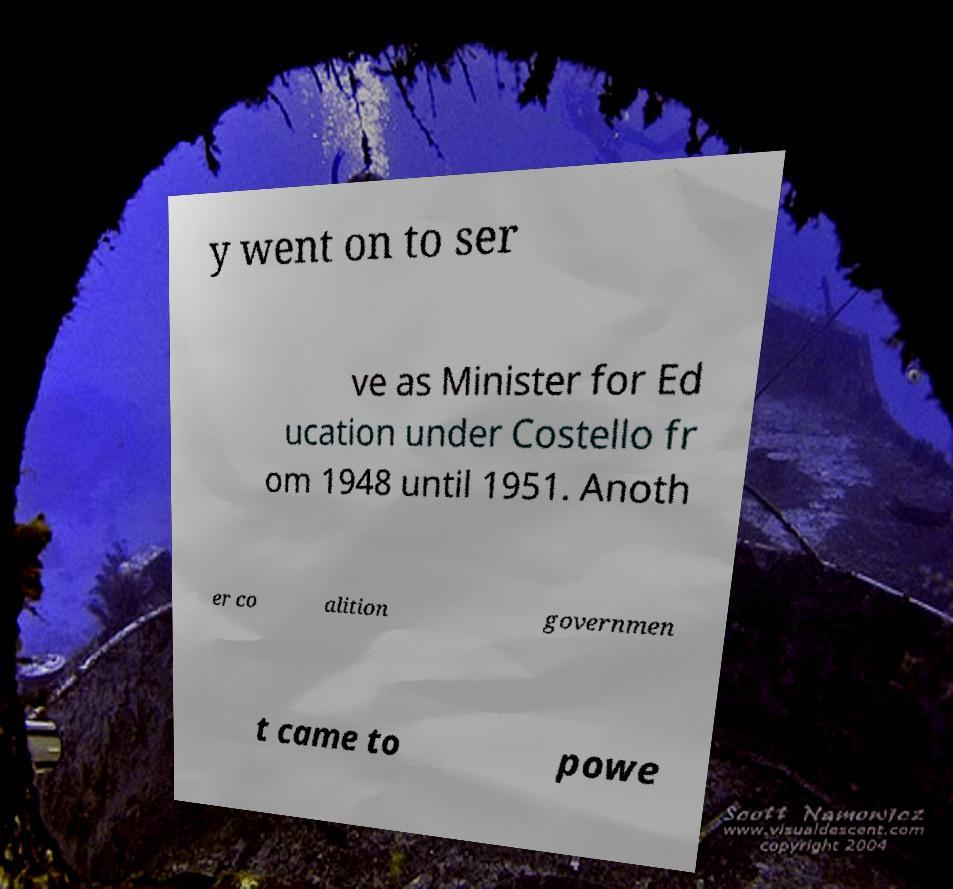Could you extract and type out the text from this image? y went on to ser ve as Minister for Ed ucation under Costello fr om 1948 until 1951. Anoth er co alition governmen t came to powe 